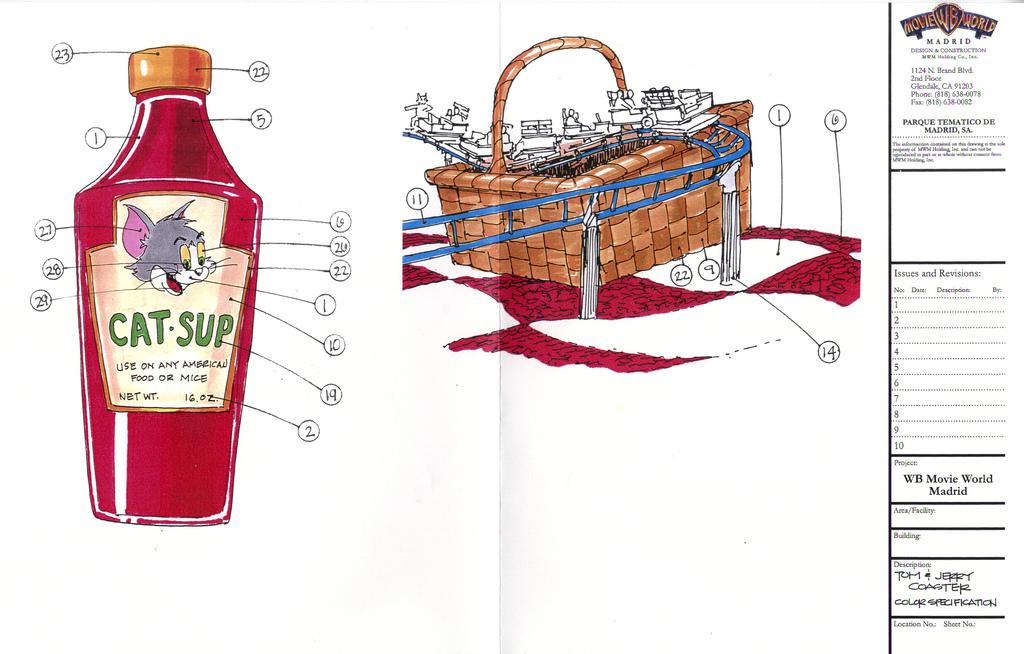What is this cartoon referencing?
Provide a short and direct response. Catsup. What animal is on the bottle?
Ensure brevity in your answer.  Cat. 